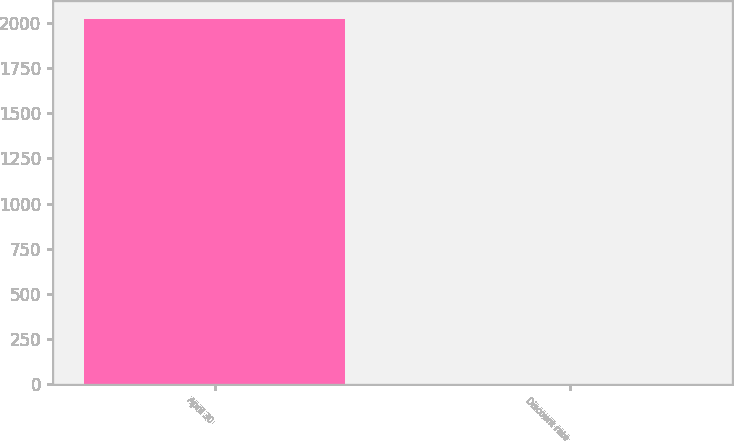Convert chart to OTSL. <chart><loc_0><loc_0><loc_500><loc_500><bar_chart><fcel>April 30<fcel>Discount rate<nl><fcel>2018<fcel>4.17<nl></chart> 